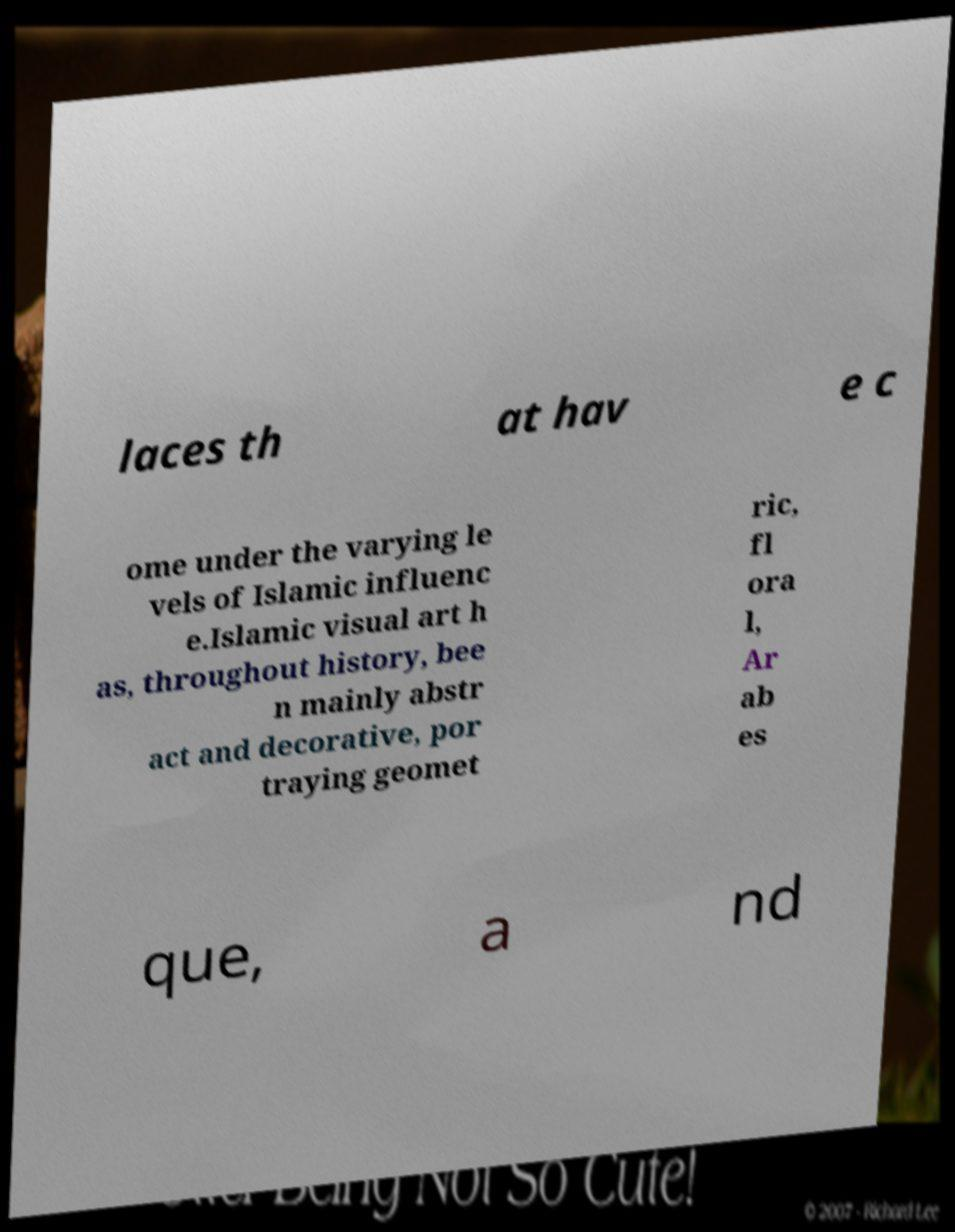I need the written content from this picture converted into text. Can you do that? laces th at hav e c ome under the varying le vels of Islamic influenc e.Islamic visual art h as, throughout history, bee n mainly abstr act and decorative, por traying geomet ric, fl ora l, Ar ab es que, a nd 